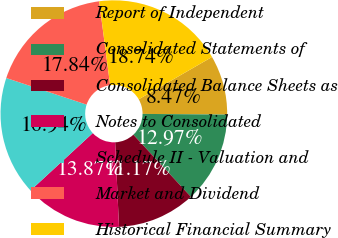Convert chart to OTSL. <chart><loc_0><loc_0><loc_500><loc_500><pie_chart><fcel>Report of Independent<fcel>Consolidated Statements of<fcel>Consolidated Balance Sheets as<fcel>Notes to Consolidated<fcel>Schedule II - Valuation and<fcel>Market and Dividend<fcel>Historical Financial Summary<nl><fcel>8.47%<fcel>12.97%<fcel>11.17%<fcel>13.87%<fcel>16.94%<fcel>17.84%<fcel>18.74%<nl></chart> 